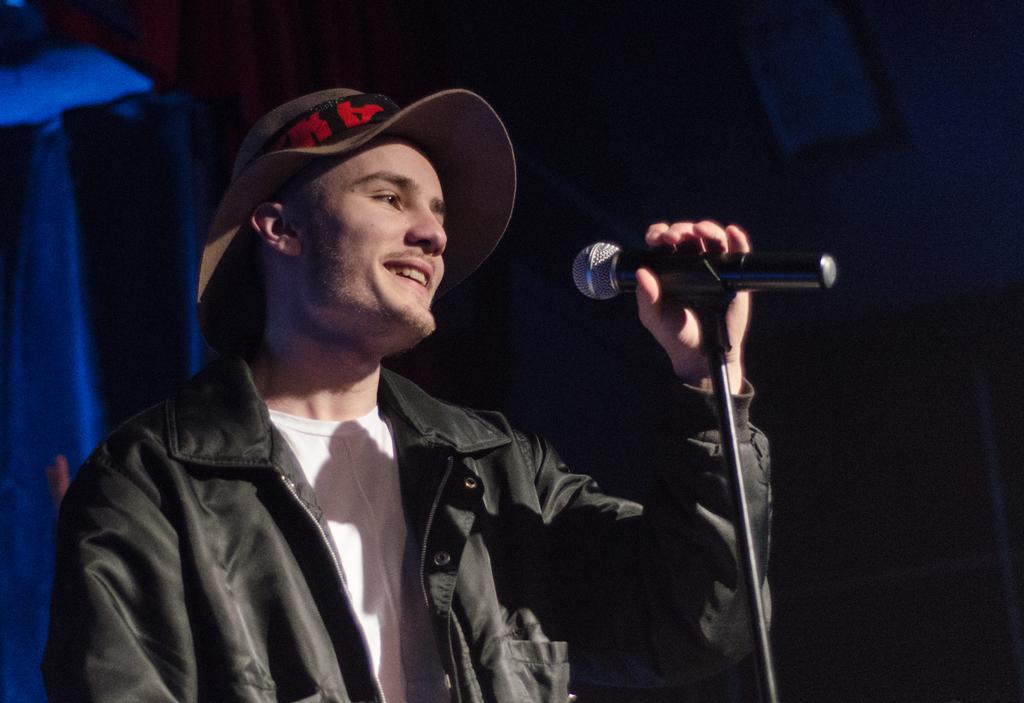Who is the main subject in the image? There is a man in the image. What is the man wearing on his head? The man is wearing a hat. What color is the jacket the man is wearing? The man is wearing a black jacket. What is the man doing in the image? The man is standing in front of a mic and holding it. What is the man's facial expression in the image? The man is smiling. What type of texture can be seen on the truck in the image? There is no truck present in the image; it features a man standing in front of a mic. 